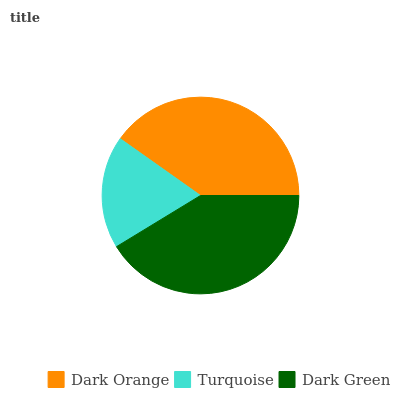Is Turquoise the minimum?
Answer yes or no. Yes. Is Dark Green the maximum?
Answer yes or no. Yes. Is Dark Green the minimum?
Answer yes or no. No. Is Turquoise the maximum?
Answer yes or no. No. Is Dark Green greater than Turquoise?
Answer yes or no. Yes. Is Turquoise less than Dark Green?
Answer yes or no. Yes. Is Turquoise greater than Dark Green?
Answer yes or no. No. Is Dark Green less than Turquoise?
Answer yes or no. No. Is Dark Orange the high median?
Answer yes or no. Yes. Is Dark Orange the low median?
Answer yes or no. Yes. Is Turquoise the high median?
Answer yes or no. No. Is Dark Green the low median?
Answer yes or no. No. 